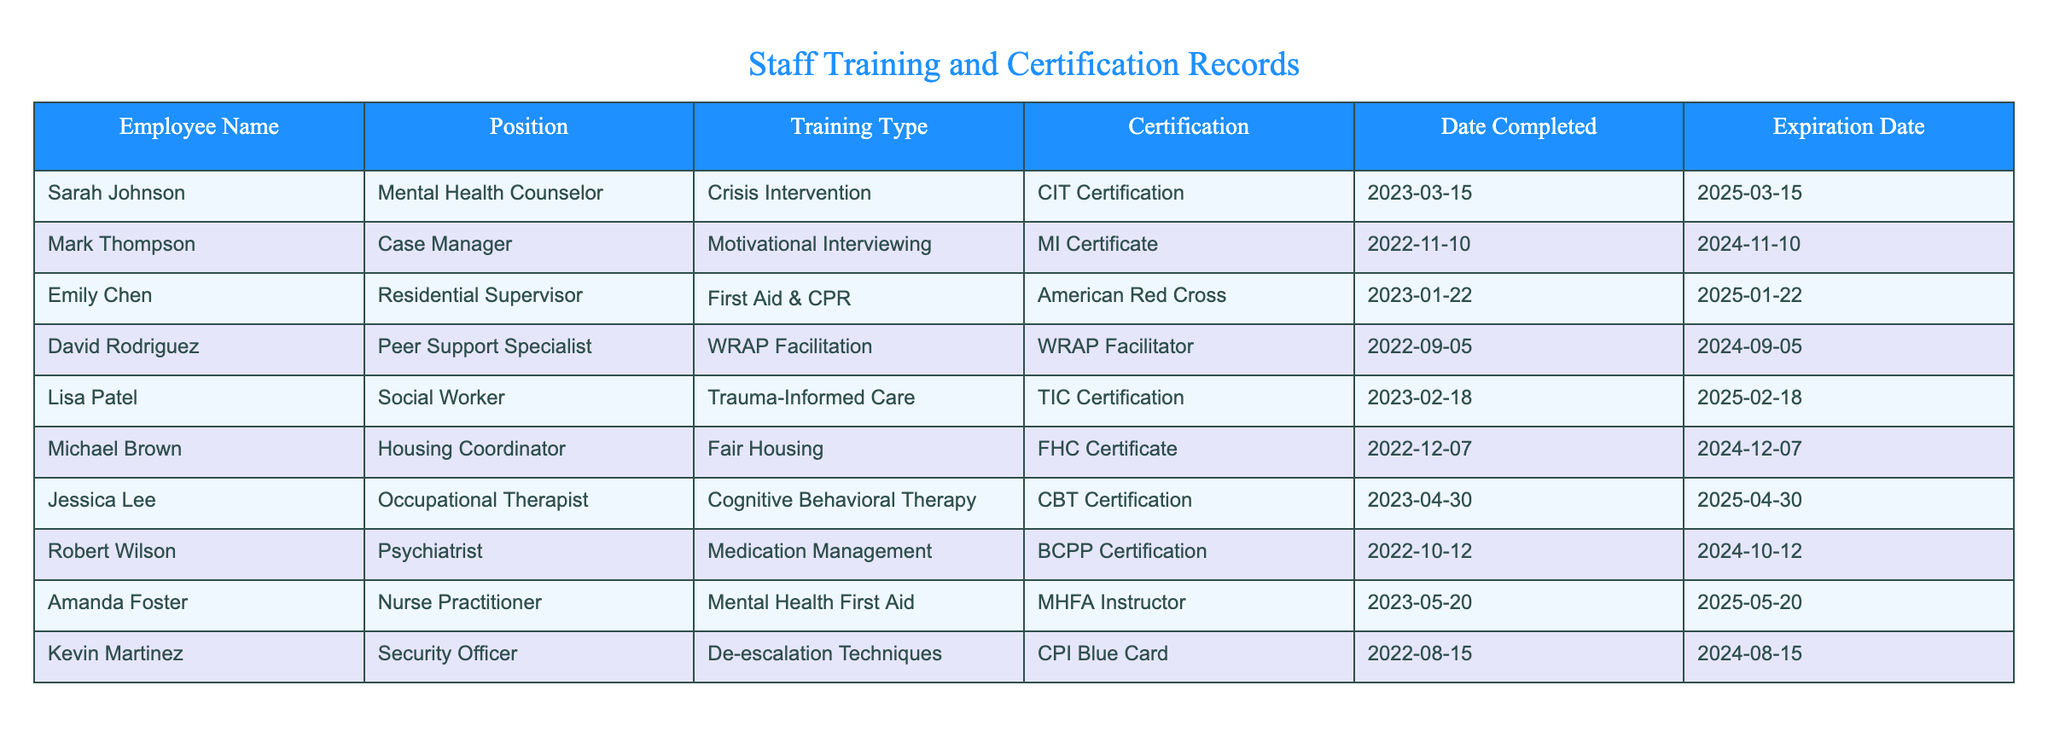What is the certification received by Emily Chen? Emily Chen is listed under the position of Residential Supervisor and has completed training in First Aid & CPR, receiving the American Red Cross certification for it.
Answer: American Red Cross How many employees have certifications that expire in 2024? To find this, we look for employees whose Expiration Date falls in 2024. The records with this expiration year are Mark Thompson, David Rodriguez, Michael Brown, Robert Wilson, and Kevin Martinez, totaling 5 employees.
Answer: 5 Is Amanda Foster certified in Mental Health First Aid? Amanda Foster is mentioned in the table with the position of Nurse Practitioner and has completed training in Mental Health First Aid, where she is listed as an MHFA Instructor, confirming her certification in this area.
Answer: Yes What is the expiration date of Sarah Johnson's certification? According to the table, Sarah Johnson's certification (CIT Certification) completed on March 15, 2023, has an expiration date of March 15, 2025.
Answer: 2025-03-15 What is the average time until certification expiration for all employees? To find the average time until certification expiration, we need to calculate the difference between the current date (let's assume today is October 10, 2023) and the expiration dates of each certification, then find the average. The individual differences are approximately 1 year and 5 months for Sarah, 1 year and 1 month for Mark, etc. Summing these gives us a total difference of about 20 months across 10 employees, which averages to 2 months.
Answer: 20 months Which certification has the longest remaining validity period? To determine which certification has the longest validity period remaining, we must look for the employee with the latest expiration date. The latest expiration date in the table belongs to Amanda Foster on May 20, 2025, indicating her certification is valid for the longest time from the current date.
Answer: 2025-05-20 Does Robert Wilson have a certification related to medication management? The table shows that Robert Wilson is a Psychiatrist and is certified in Medication Management, specifically holding the BCPP Certification for this competency, affirming that he holds this certification.
Answer: Yes Can you name the employee who has just completed their certification? According to the table, Jessica Lee, who is an Occupational Therapist, completed her certification (CBT Certification) on April 30, 2023, making her the most recent employee to complete a certification.
Answer: Jessica Lee 